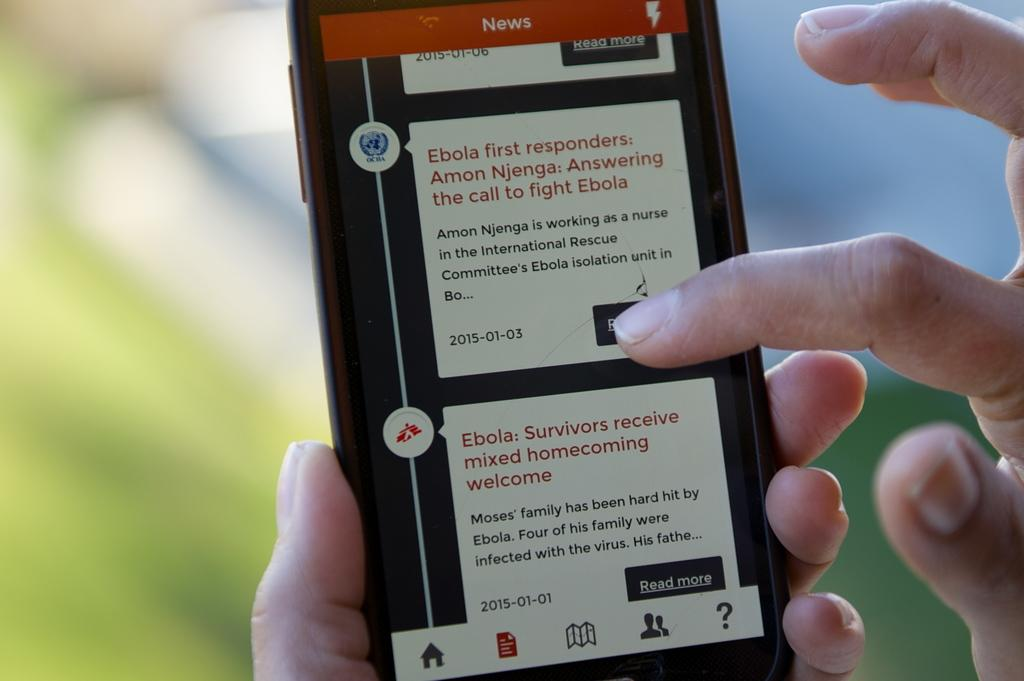<image>
Present a compact description of the photo's key features. A hand holding a cell phone with an article about ebola on the screen. 